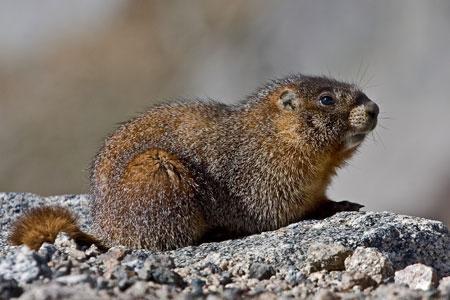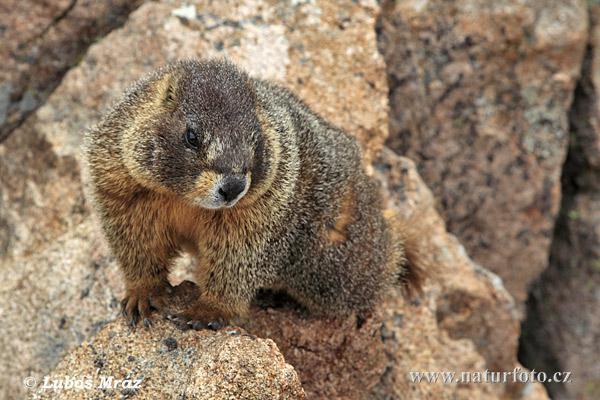The first image is the image on the left, the second image is the image on the right. Given the left and right images, does the statement "An image shows an upright rodent-type animal." hold true? Answer yes or no. No. 